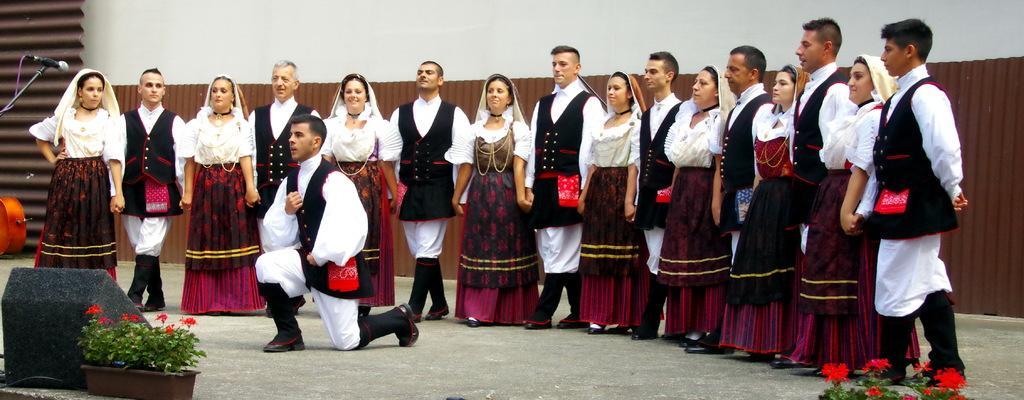Can you describe this image briefly? In this image I can see group of people standing. In front the person is wearing black and white color dress and I can see few flowers in red color, plants in green color and I can also see a microphone, background the wall is in white color. 